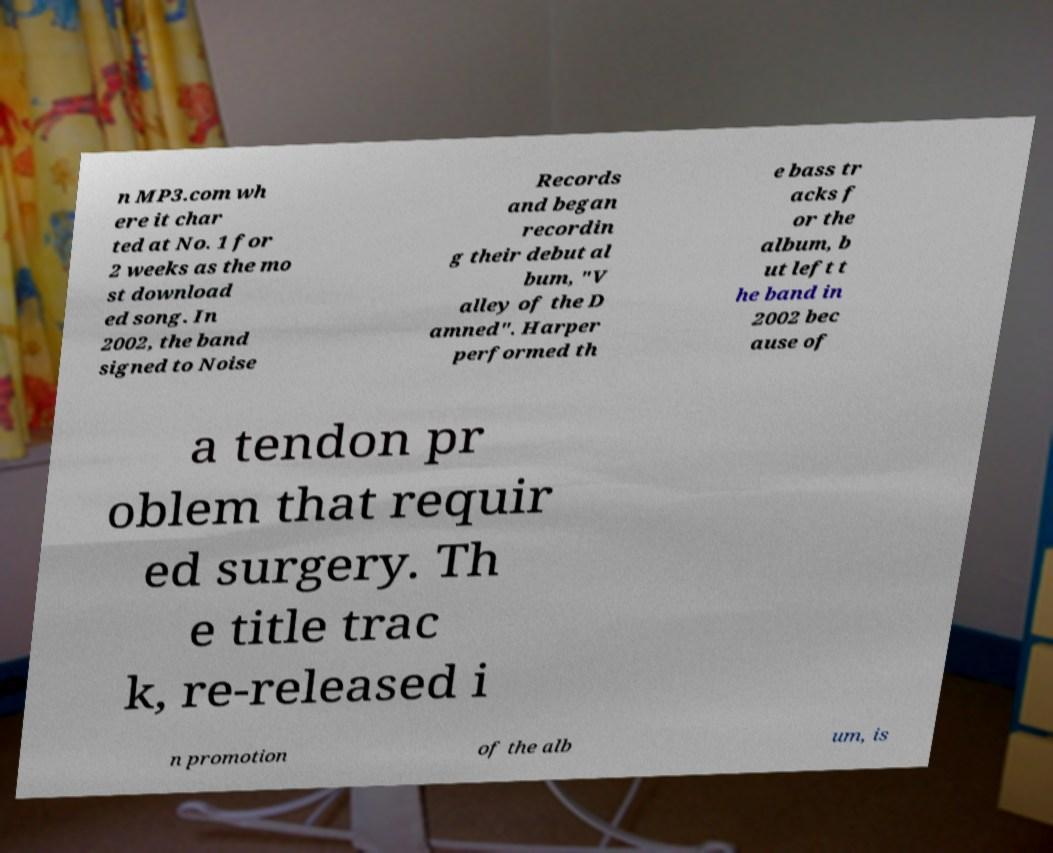There's text embedded in this image that I need extracted. Can you transcribe it verbatim? n MP3.com wh ere it char ted at No. 1 for 2 weeks as the mo st download ed song. In 2002, the band signed to Noise Records and began recordin g their debut al bum, "V alley of the D amned". Harper performed th e bass tr acks f or the album, b ut left t he band in 2002 bec ause of a tendon pr oblem that requir ed surgery. Th e title trac k, re-released i n promotion of the alb um, is 